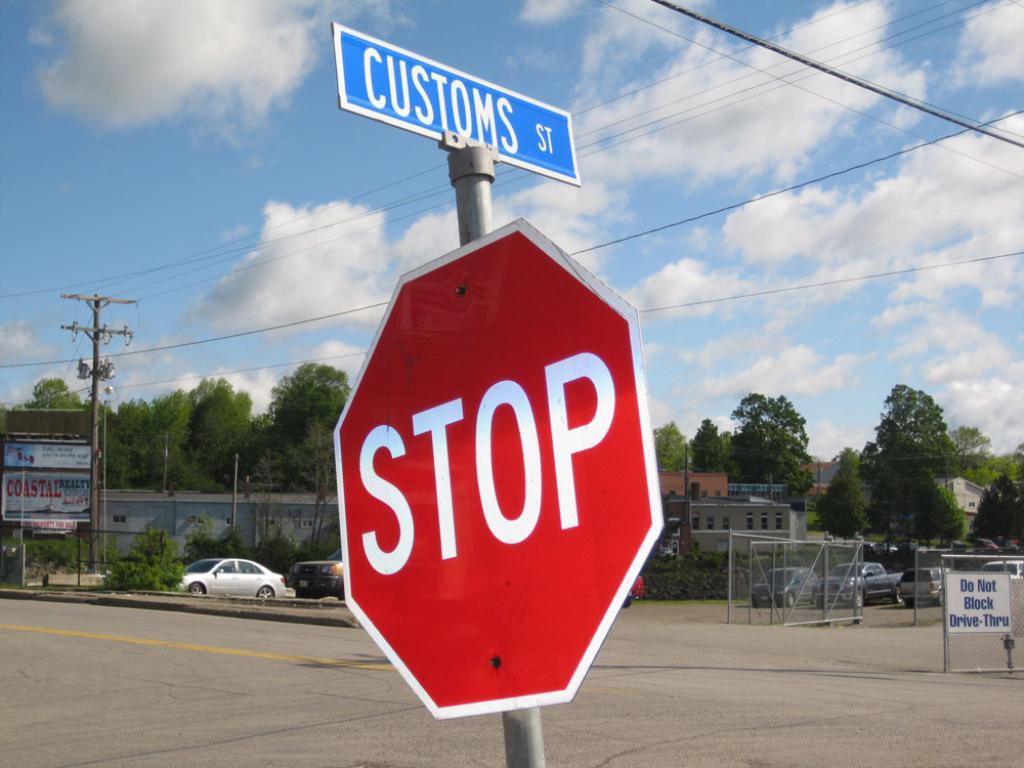<image>
Relay a brief, clear account of the picture shown. A blue street sign for Customs Street is mounted above a red stop sign. 